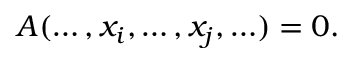<formula> <loc_0><loc_0><loc_500><loc_500>A ( \dots , x _ { i } , \dots , x _ { j } , \dots ) = 0 .</formula> 